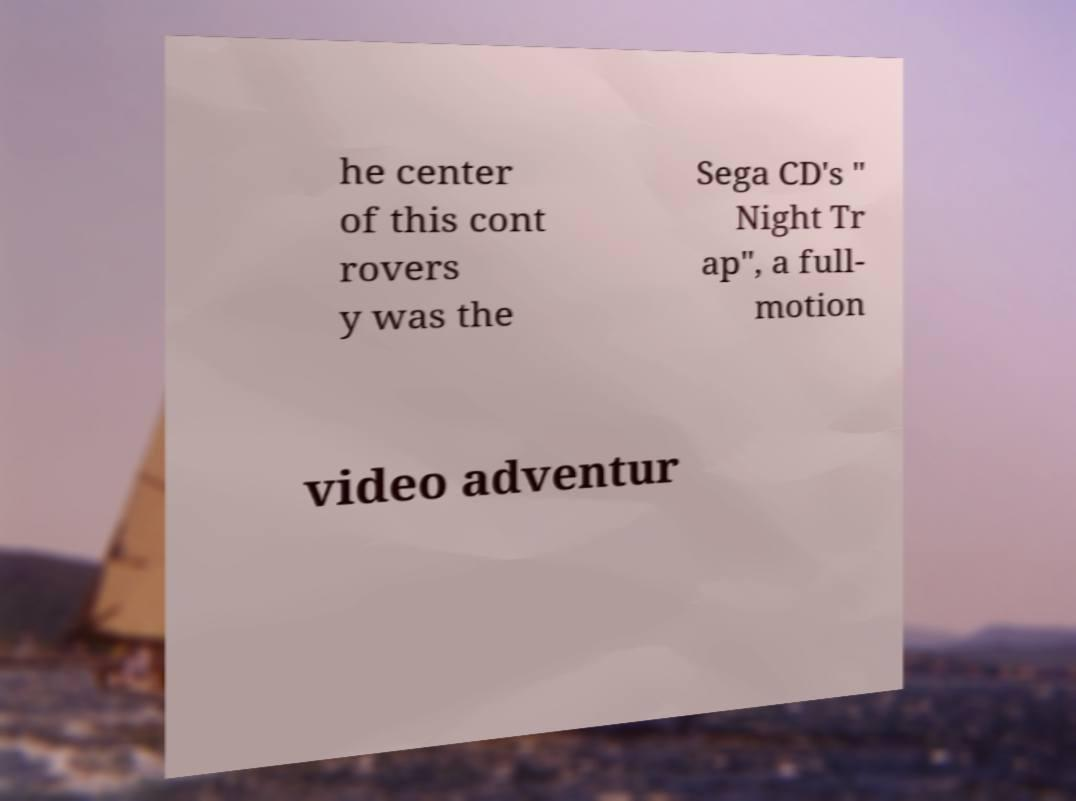Can you accurately transcribe the text from the provided image for me? he center of this cont rovers y was the Sega CD's " Night Tr ap", a full- motion video adventur 